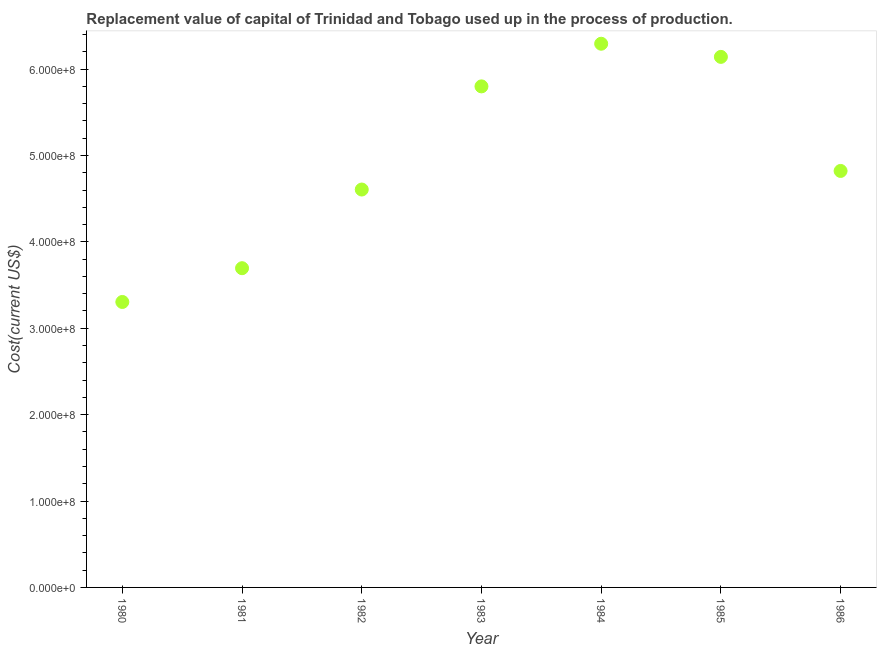What is the consumption of fixed capital in 1983?
Offer a very short reply. 5.80e+08. Across all years, what is the maximum consumption of fixed capital?
Your answer should be very brief. 6.29e+08. Across all years, what is the minimum consumption of fixed capital?
Your answer should be compact. 3.30e+08. In which year was the consumption of fixed capital maximum?
Offer a terse response. 1984. What is the sum of the consumption of fixed capital?
Your response must be concise. 3.47e+09. What is the difference between the consumption of fixed capital in 1981 and 1985?
Your response must be concise. -2.45e+08. What is the average consumption of fixed capital per year?
Provide a short and direct response. 4.95e+08. What is the median consumption of fixed capital?
Provide a succinct answer. 4.82e+08. Do a majority of the years between 1983 and 1984 (inclusive) have consumption of fixed capital greater than 60000000 US$?
Your answer should be compact. Yes. What is the ratio of the consumption of fixed capital in 1983 to that in 1985?
Offer a very short reply. 0.94. Is the consumption of fixed capital in 1985 less than that in 1986?
Your response must be concise. No. Is the difference between the consumption of fixed capital in 1983 and 1986 greater than the difference between any two years?
Ensure brevity in your answer.  No. What is the difference between the highest and the second highest consumption of fixed capital?
Provide a succinct answer. 1.52e+07. What is the difference between the highest and the lowest consumption of fixed capital?
Ensure brevity in your answer.  2.99e+08. Does the consumption of fixed capital monotonically increase over the years?
Your answer should be compact. No. How many dotlines are there?
Provide a succinct answer. 1. What is the difference between two consecutive major ticks on the Y-axis?
Make the answer very short. 1.00e+08. Does the graph contain grids?
Ensure brevity in your answer.  No. What is the title of the graph?
Offer a very short reply. Replacement value of capital of Trinidad and Tobago used up in the process of production. What is the label or title of the Y-axis?
Provide a succinct answer. Cost(current US$). What is the Cost(current US$) in 1980?
Offer a very short reply. 3.30e+08. What is the Cost(current US$) in 1981?
Ensure brevity in your answer.  3.70e+08. What is the Cost(current US$) in 1982?
Make the answer very short. 4.61e+08. What is the Cost(current US$) in 1983?
Offer a terse response. 5.80e+08. What is the Cost(current US$) in 1984?
Give a very brief answer. 6.29e+08. What is the Cost(current US$) in 1985?
Ensure brevity in your answer.  6.14e+08. What is the Cost(current US$) in 1986?
Ensure brevity in your answer.  4.82e+08. What is the difference between the Cost(current US$) in 1980 and 1981?
Your response must be concise. -3.91e+07. What is the difference between the Cost(current US$) in 1980 and 1982?
Your answer should be compact. -1.30e+08. What is the difference between the Cost(current US$) in 1980 and 1983?
Your answer should be very brief. -2.50e+08. What is the difference between the Cost(current US$) in 1980 and 1984?
Provide a succinct answer. -2.99e+08. What is the difference between the Cost(current US$) in 1980 and 1985?
Your answer should be very brief. -2.84e+08. What is the difference between the Cost(current US$) in 1980 and 1986?
Offer a terse response. -1.52e+08. What is the difference between the Cost(current US$) in 1981 and 1982?
Provide a short and direct response. -9.11e+07. What is the difference between the Cost(current US$) in 1981 and 1983?
Provide a succinct answer. -2.10e+08. What is the difference between the Cost(current US$) in 1981 and 1984?
Your answer should be compact. -2.60e+08. What is the difference between the Cost(current US$) in 1981 and 1985?
Keep it short and to the point. -2.45e+08. What is the difference between the Cost(current US$) in 1981 and 1986?
Your answer should be very brief. -1.13e+08. What is the difference between the Cost(current US$) in 1982 and 1983?
Make the answer very short. -1.19e+08. What is the difference between the Cost(current US$) in 1982 and 1984?
Offer a terse response. -1.69e+08. What is the difference between the Cost(current US$) in 1982 and 1985?
Make the answer very short. -1.54e+08. What is the difference between the Cost(current US$) in 1982 and 1986?
Your answer should be compact. -2.15e+07. What is the difference between the Cost(current US$) in 1983 and 1984?
Ensure brevity in your answer.  -4.94e+07. What is the difference between the Cost(current US$) in 1983 and 1985?
Offer a very short reply. -3.41e+07. What is the difference between the Cost(current US$) in 1983 and 1986?
Give a very brief answer. 9.79e+07. What is the difference between the Cost(current US$) in 1984 and 1985?
Offer a very short reply. 1.52e+07. What is the difference between the Cost(current US$) in 1984 and 1986?
Your answer should be compact. 1.47e+08. What is the difference between the Cost(current US$) in 1985 and 1986?
Provide a short and direct response. 1.32e+08. What is the ratio of the Cost(current US$) in 1980 to that in 1981?
Offer a very short reply. 0.89. What is the ratio of the Cost(current US$) in 1980 to that in 1982?
Your answer should be very brief. 0.72. What is the ratio of the Cost(current US$) in 1980 to that in 1983?
Offer a very short reply. 0.57. What is the ratio of the Cost(current US$) in 1980 to that in 1984?
Offer a terse response. 0.53. What is the ratio of the Cost(current US$) in 1980 to that in 1985?
Your response must be concise. 0.54. What is the ratio of the Cost(current US$) in 1980 to that in 1986?
Your answer should be compact. 0.69. What is the ratio of the Cost(current US$) in 1981 to that in 1982?
Your response must be concise. 0.8. What is the ratio of the Cost(current US$) in 1981 to that in 1983?
Offer a terse response. 0.64. What is the ratio of the Cost(current US$) in 1981 to that in 1984?
Your answer should be very brief. 0.59. What is the ratio of the Cost(current US$) in 1981 to that in 1985?
Make the answer very short. 0.6. What is the ratio of the Cost(current US$) in 1981 to that in 1986?
Keep it short and to the point. 0.77. What is the ratio of the Cost(current US$) in 1982 to that in 1983?
Keep it short and to the point. 0.79. What is the ratio of the Cost(current US$) in 1982 to that in 1984?
Make the answer very short. 0.73. What is the ratio of the Cost(current US$) in 1982 to that in 1986?
Your response must be concise. 0.95. What is the ratio of the Cost(current US$) in 1983 to that in 1984?
Provide a short and direct response. 0.92. What is the ratio of the Cost(current US$) in 1983 to that in 1985?
Your response must be concise. 0.94. What is the ratio of the Cost(current US$) in 1983 to that in 1986?
Ensure brevity in your answer.  1.2. What is the ratio of the Cost(current US$) in 1984 to that in 1986?
Give a very brief answer. 1.3. What is the ratio of the Cost(current US$) in 1985 to that in 1986?
Offer a very short reply. 1.27. 